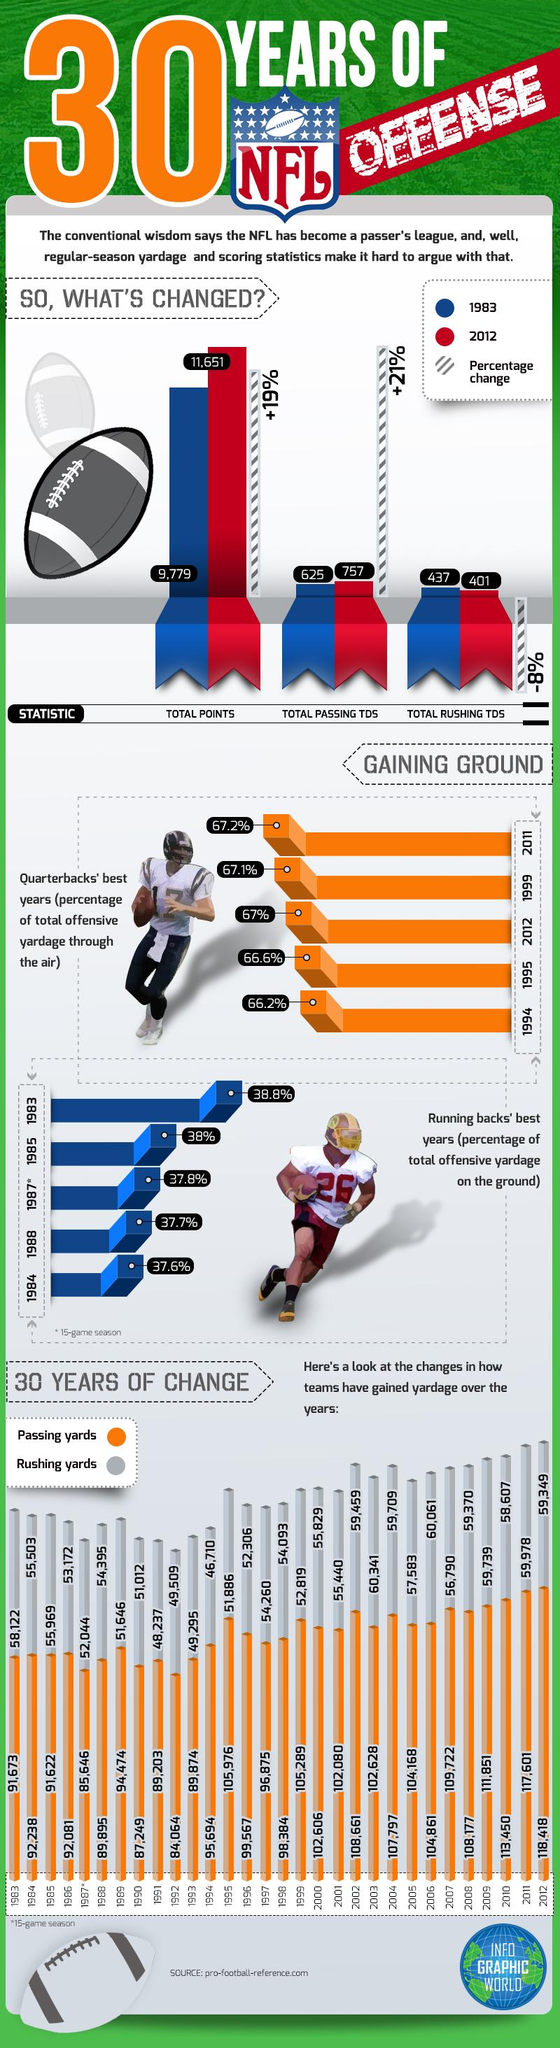List a handful of essential elements in this visual. In 2012, the total amount of passing TDS in NFL games was 757. In the National Football League games played in 1983, the total rushing touchdowns amounted to 437. In 1985, the percentage of total offensive yardage gained on the ground was 38%. The percentage change in the total passing TDS in NFL games from 1983 to 2012 was +21%. The total points scored in NFL games increased by 19% from 1983 to 2012. 